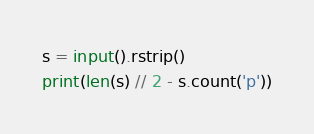Convert code to text. <code><loc_0><loc_0><loc_500><loc_500><_Python_>s = input().rstrip()
print(len(s) // 2 - s.count('p'))</code> 